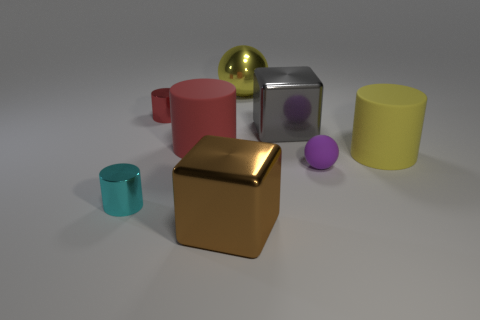What material is the gray object that is the same size as the yellow rubber cylinder?
Ensure brevity in your answer.  Metal. Is the size of the matte cylinder to the right of the red matte thing the same as the purple matte object?
Make the answer very short. No. There is a big yellow object that is on the left side of the gray metallic object; what is it made of?
Ensure brevity in your answer.  Metal. There is a metal thing that is behind the cyan metal cylinder and in front of the red shiny thing; what is its size?
Offer a very short reply. Large. What is the size of the metal cylinder that is in front of the small metallic cylinder behind the small cyan metallic thing in front of the big red matte thing?
Offer a very short reply. Small. What number of other things are the same color as the tiny rubber sphere?
Make the answer very short. 0. Is the color of the tiny metal object that is to the right of the small cyan cylinder the same as the metallic ball?
Your answer should be very brief. No. What number of objects are either rubber balls or big red matte cylinders?
Give a very brief answer. 2. There is a sphere left of the purple object; what color is it?
Keep it short and to the point. Yellow. Is the number of small red metal cylinders that are on the right side of the large yellow metal ball less than the number of big yellow rubber things?
Your answer should be compact. Yes. 